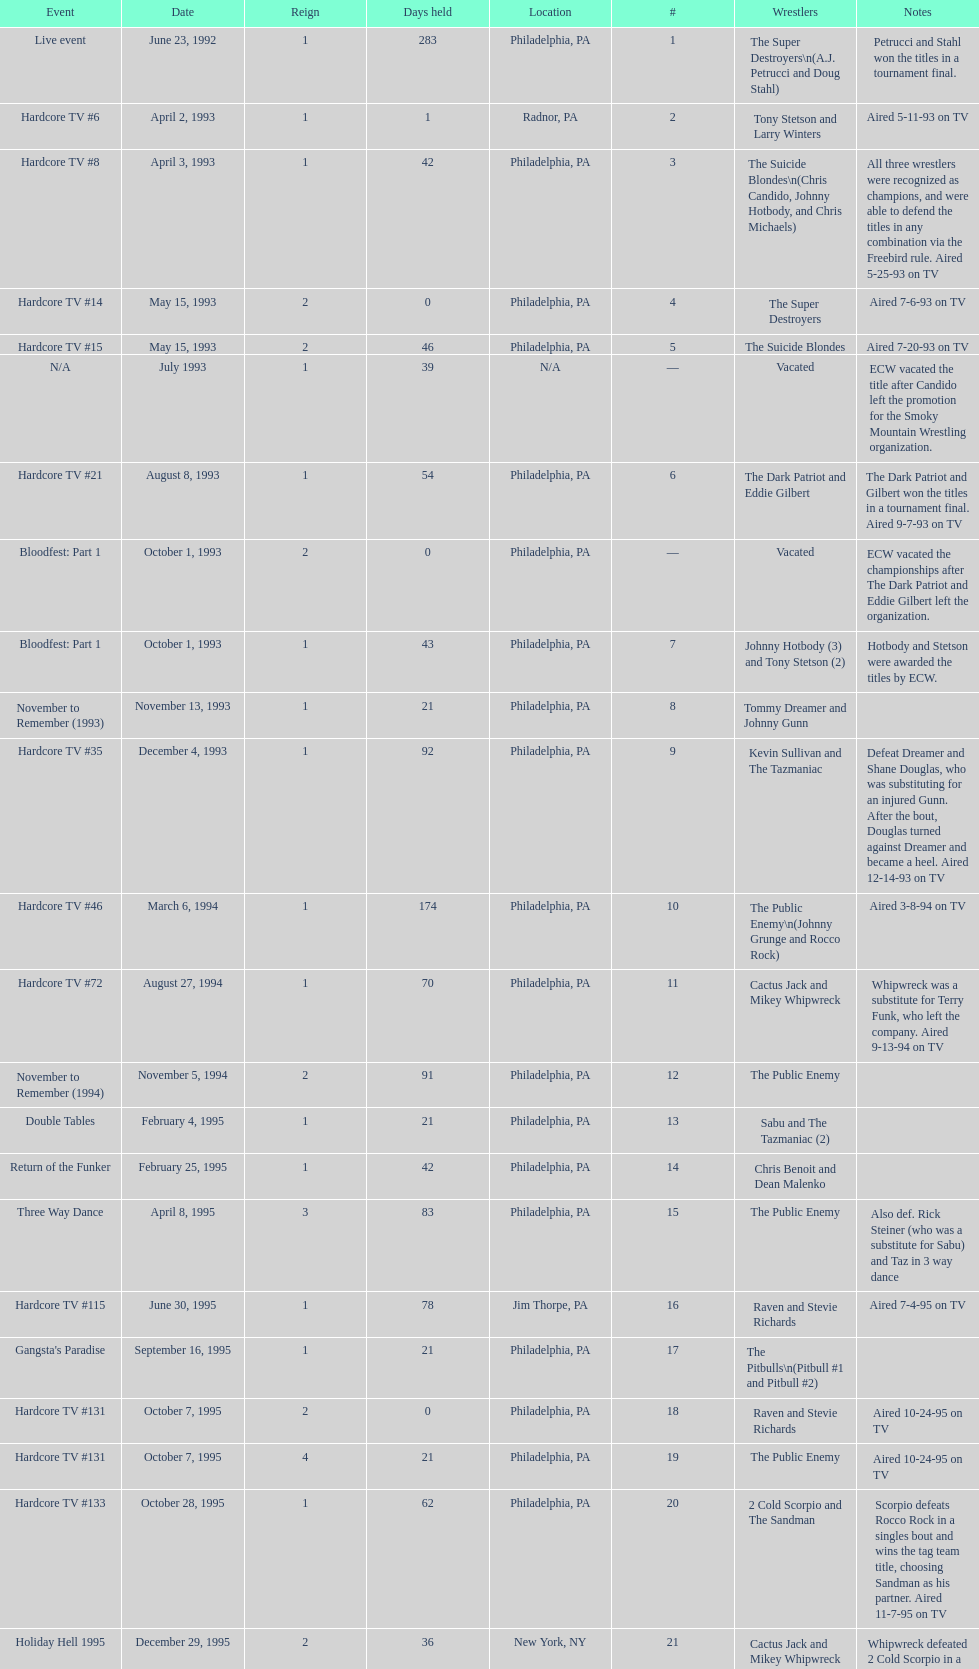Which was the only team to win by forfeit? The Dudley Boyz. 